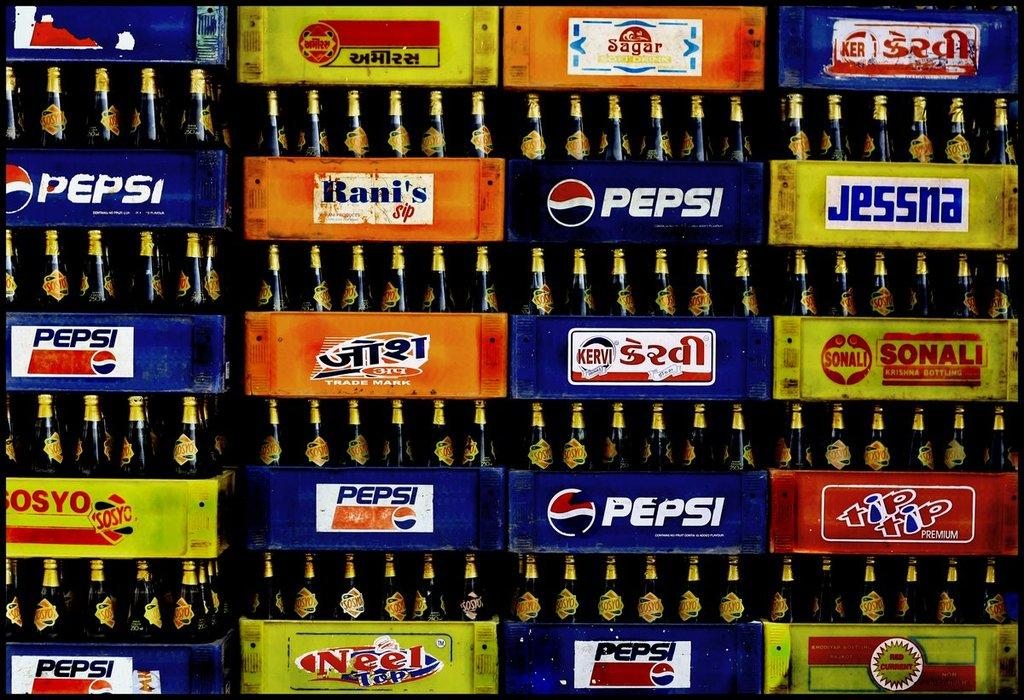<image>
Give a short and clear explanation of the subsequent image. Bottles of soda such as Pepsi and Jessna are stacked in rows. 